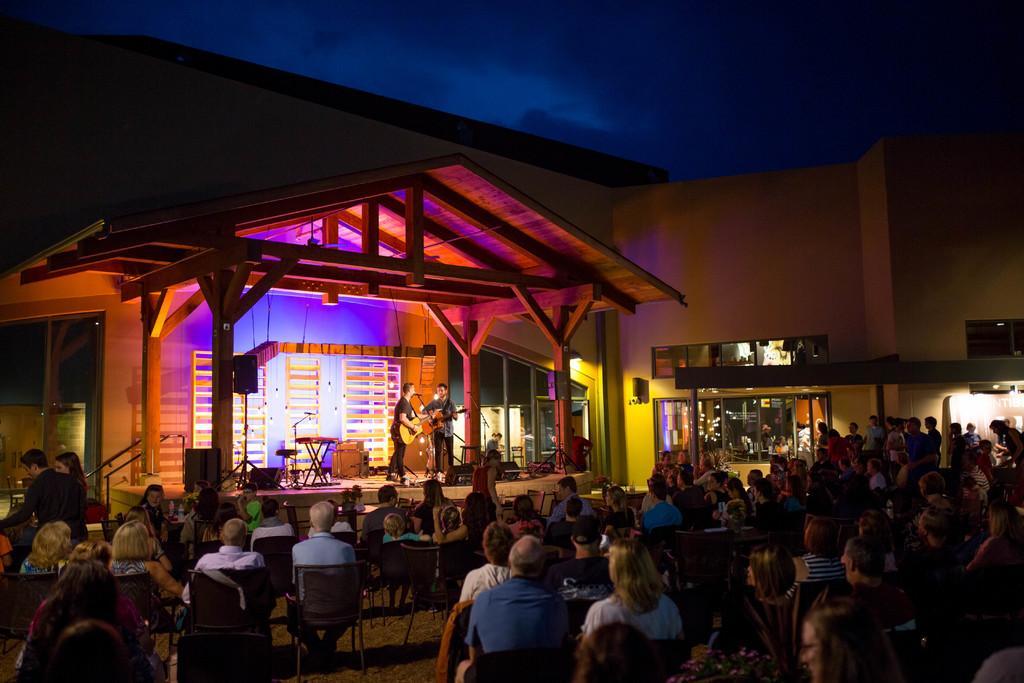Please provide a concise description of this image. There is a crowd sitting on the chairs at the bottom of this image. There are two persons standing and holding a guitars on the stage as we can see in the middle of this image. There is a building in the in the background. There is a sky at the top of this image. 